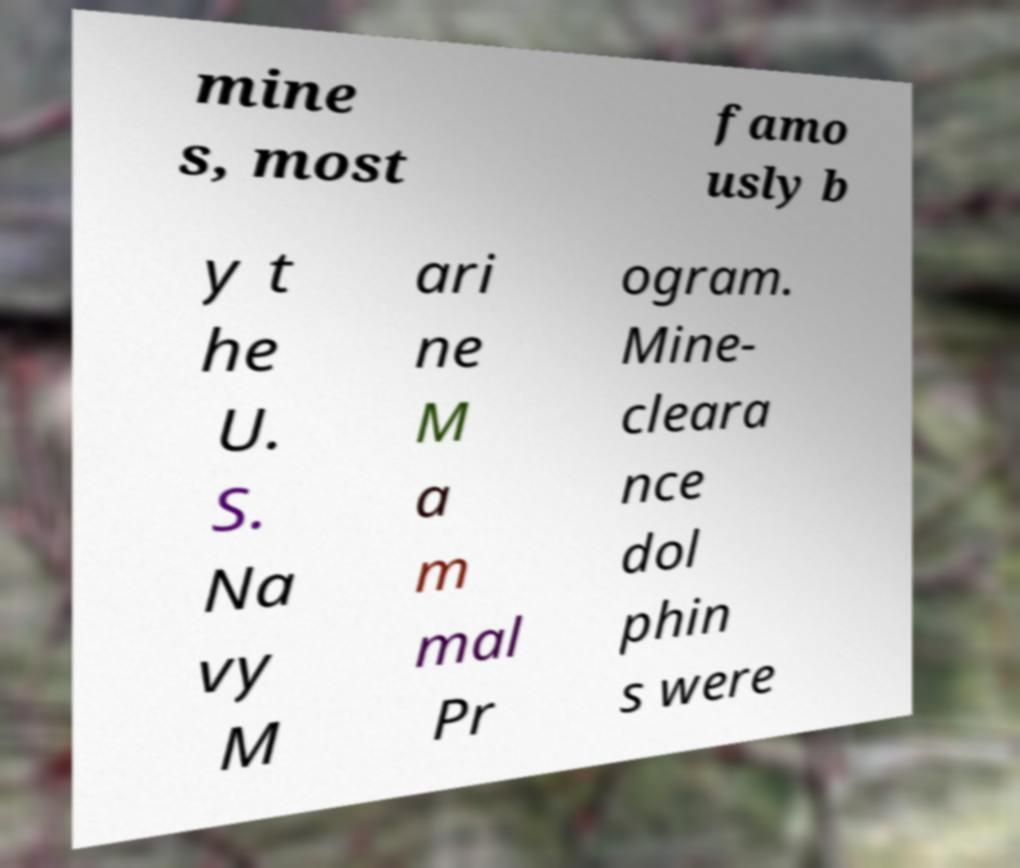Could you extract and type out the text from this image? mine s, most famo usly b y t he U. S. Na vy M ari ne M a m mal Pr ogram. Mine- cleara nce dol phin s were 